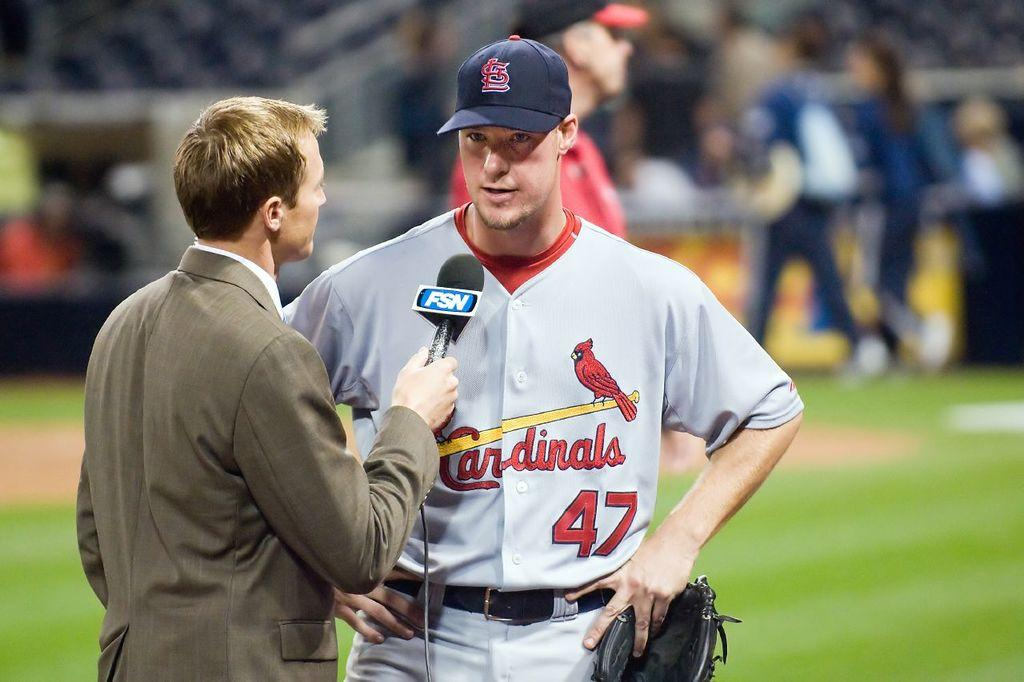<image>
Offer a succinct explanation of the picture presented. A baseball player in a Cardinals Jersey talking to a reporter. 